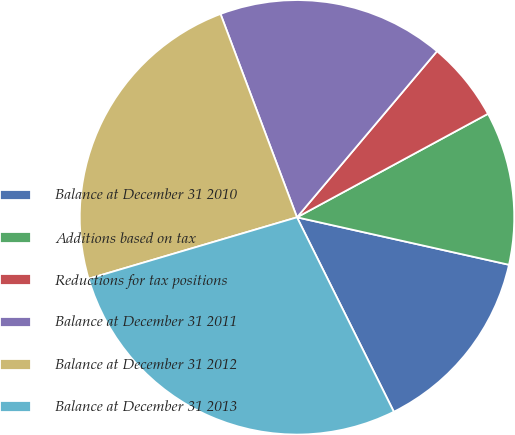Convert chart to OTSL. <chart><loc_0><loc_0><loc_500><loc_500><pie_chart><fcel>Balance at December 31 2010<fcel>Additions based on tax<fcel>Reductions for tax positions<fcel>Balance at December 31 2011<fcel>Balance at December 31 2012<fcel>Balance at December 31 2013<nl><fcel>14.14%<fcel>11.41%<fcel>5.95%<fcel>16.87%<fcel>23.84%<fcel>27.79%<nl></chart> 